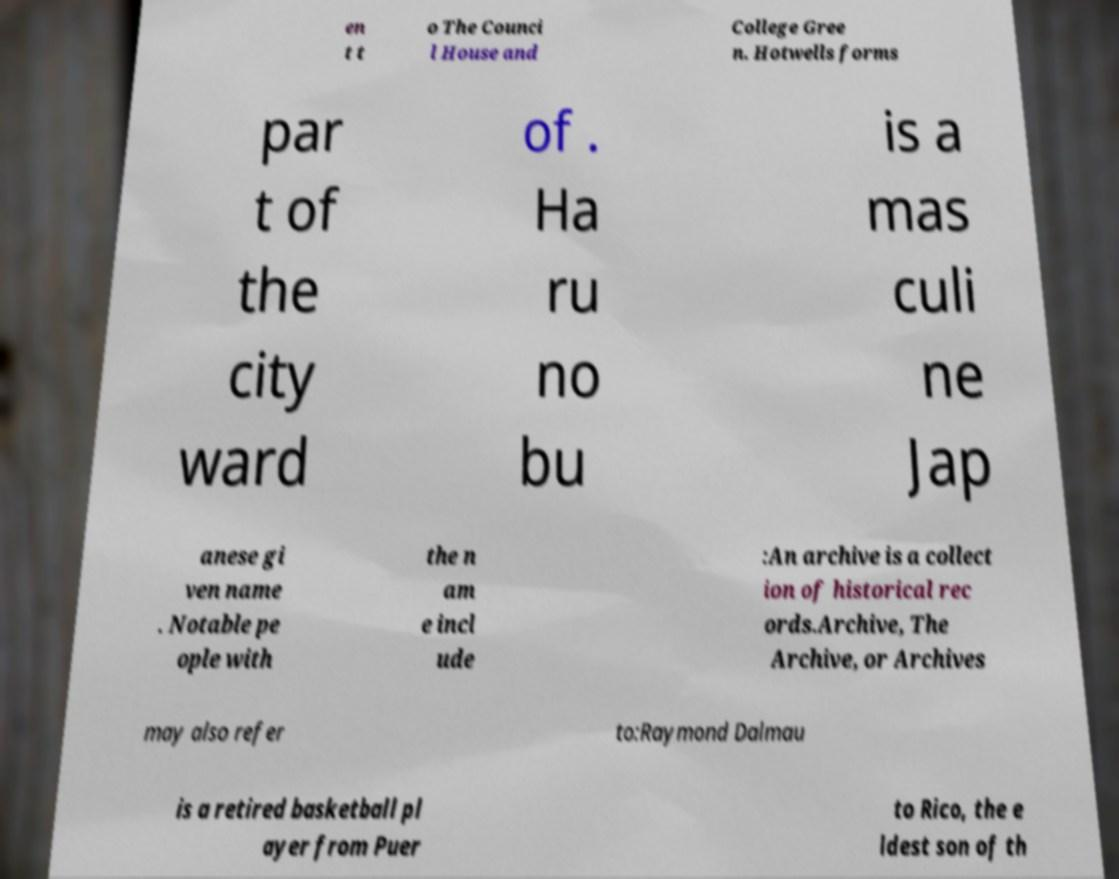There's text embedded in this image that I need extracted. Can you transcribe it verbatim? en t t o The Counci l House and College Gree n. Hotwells forms par t of the city ward of . Ha ru no bu is a mas culi ne Jap anese gi ven name . Notable pe ople with the n am e incl ude :An archive is a collect ion of historical rec ords.Archive, The Archive, or Archives may also refer to:Raymond Dalmau is a retired basketball pl ayer from Puer to Rico, the e ldest son of th 